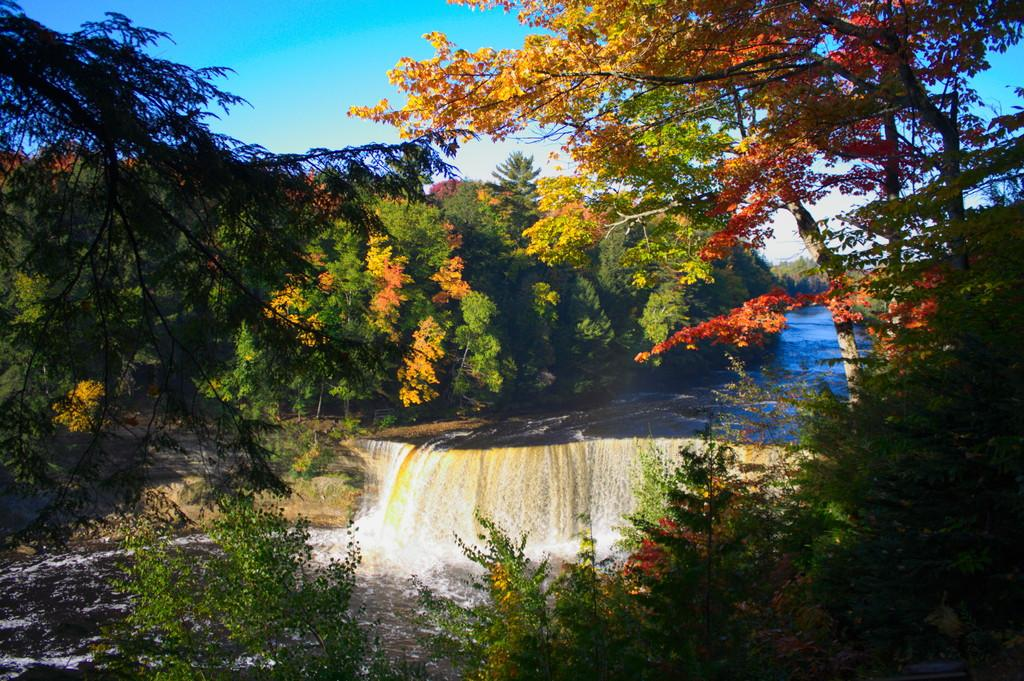What type of vegetation can be seen in the image? There are trees in the image. What natural element is visible in the image besides the trees? There is water visible in the image. What is the condition of the sky in the image? The sky is clear in the image. What colors can be seen in the sky in the image? The sky is blue and white in color. What story is being told by the trees in the image? There is no story being told by the trees in the image; they are simply trees in a natural setting. What event is taking place in the image? There is no specific event taking place in the image; it is a general scene of nature. 